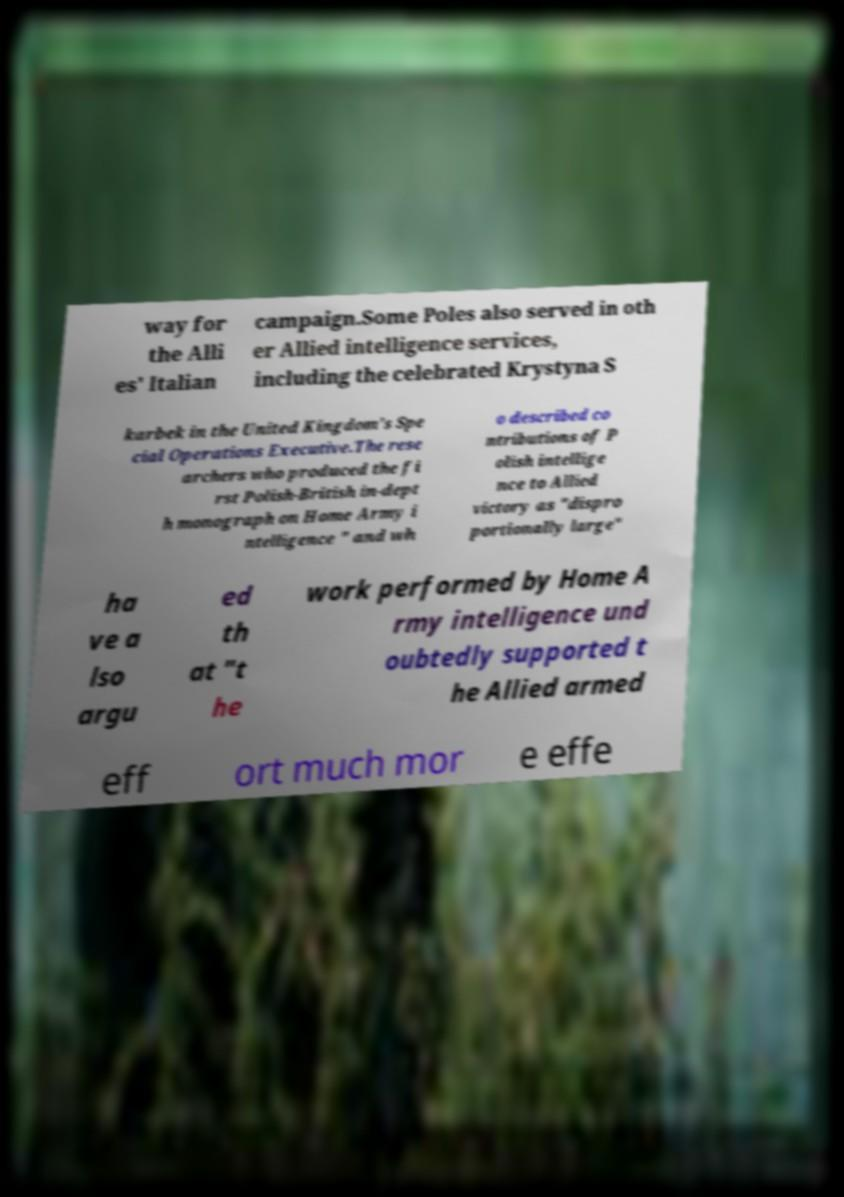Could you assist in decoding the text presented in this image and type it out clearly? way for the Alli es' Italian campaign.Some Poles also served in oth er Allied intelligence services, including the celebrated Krystyna S karbek in the United Kingdom's Spe cial Operations Executive.The rese archers who produced the fi rst Polish-British in-dept h monograph on Home Army i ntelligence " and wh o described co ntributions of P olish intellige nce to Allied victory as "dispro portionally large" ha ve a lso argu ed th at "t he work performed by Home A rmy intelligence und oubtedly supported t he Allied armed eff ort much mor e effe 